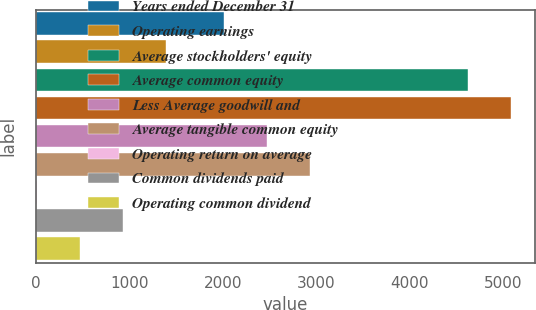<chart> <loc_0><loc_0><loc_500><loc_500><bar_chart><fcel>Years ended December 31<fcel>Operating earnings<fcel>Average stockholders' equity<fcel>Average common equity<fcel>Less Average goodwill and<fcel>Average tangible common equity<fcel>Operating return on average<fcel>Common dividends paid<fcel>Operating common dividend<nl><fcel>2014<fcel>1394.29<fcel>4625<fcel>5086.53<fcel>2475.53<fcel>2937.06<fcel>9.7<fcel>932.76<fcel>471.23<nl></chart> 